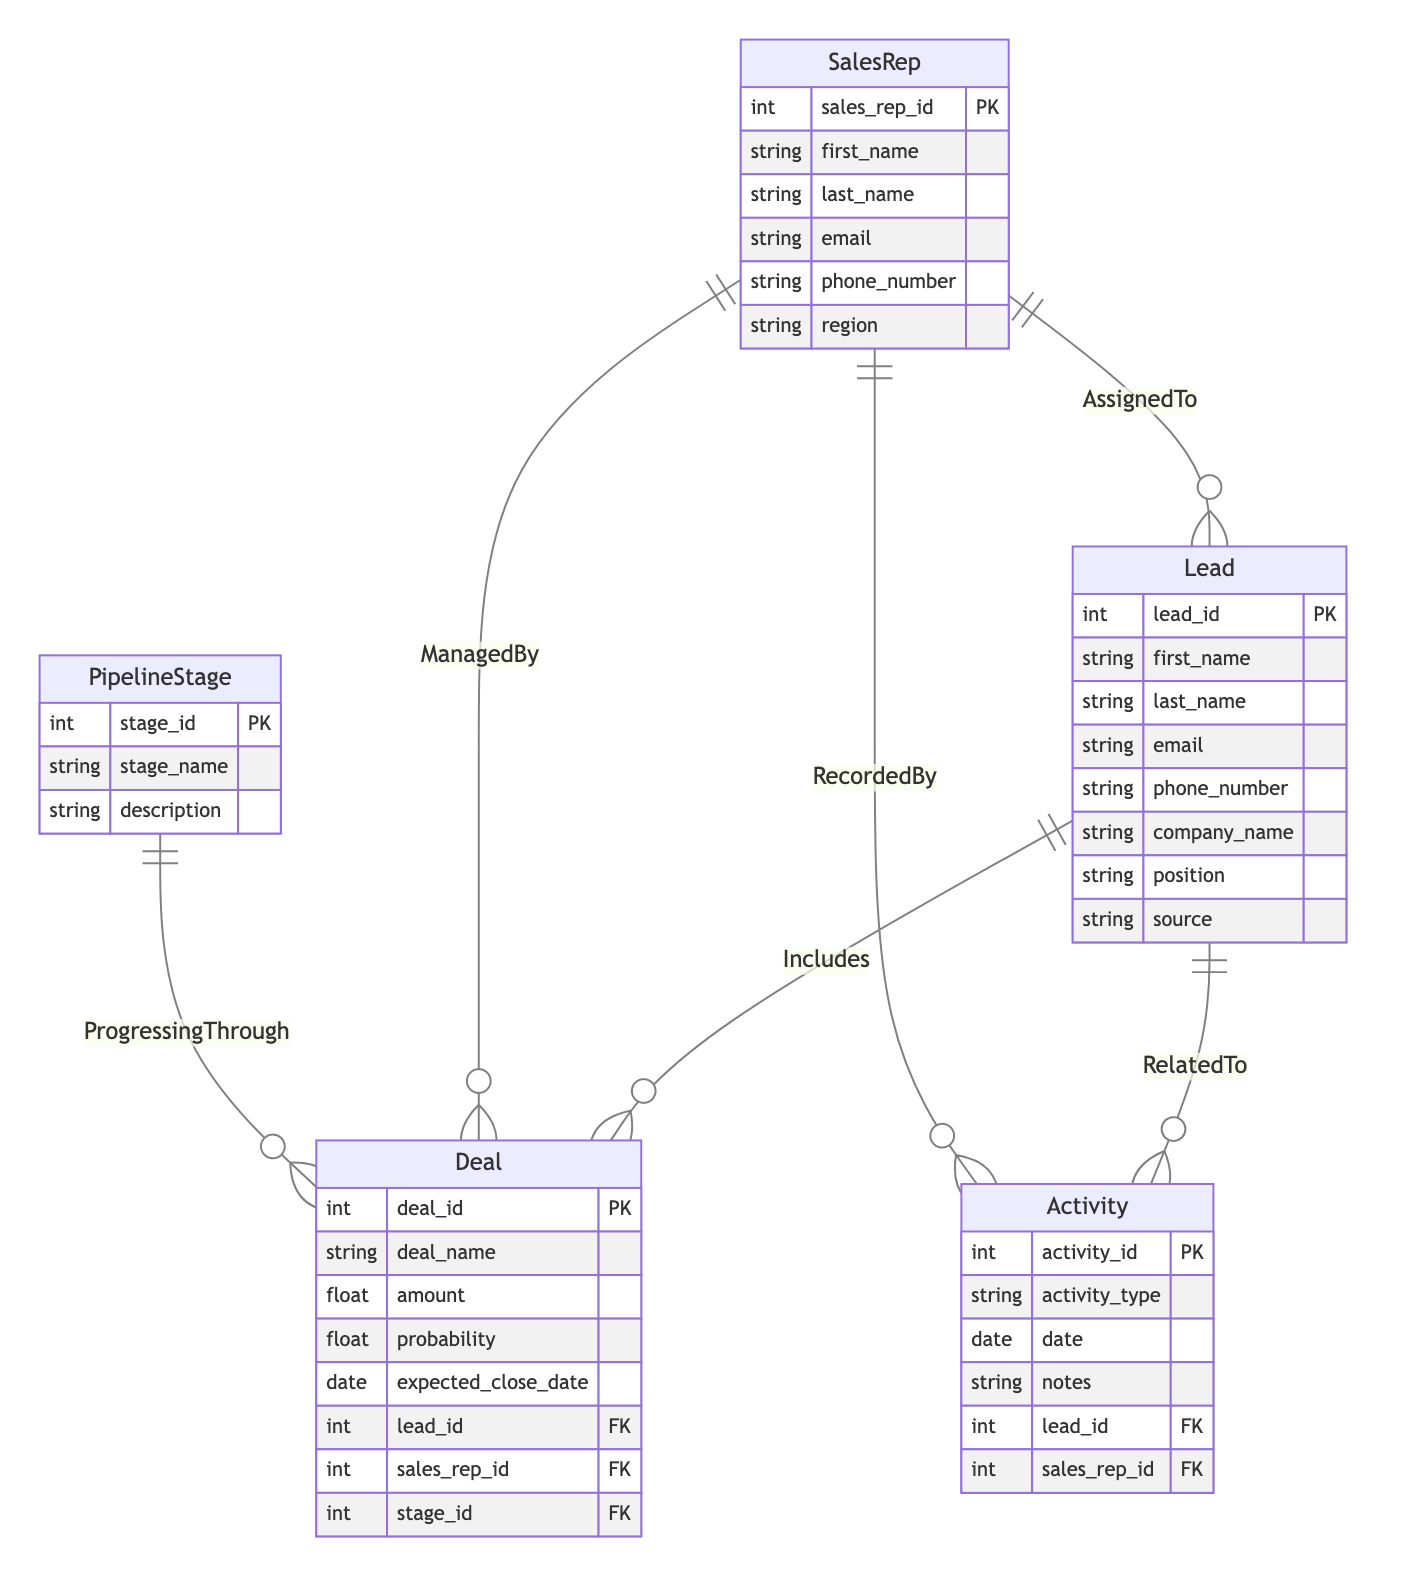What is the primary key of the Lead entity? The primary key of the Lead entity is designated by "PK" in the attributes list, which identifies lead_id as the unique identifier for each lead in this entity.
Answer: lead_id How many entities are present in the diagram? By counting the number of defined entities listed in the diagram, we find that there are five entities: Lead, SalesRep, PipelineStage, Deal, and Activity.
Answer: 5 What is the relationship type between Deal and PipelineStage? The relationship between Deal and PipelineStage is indicated as "ManyToOne," meaning multiple Deals can progress through a single PipelineStage, which is denoted in the relationships section.
Answer: ManyToOne Which entity is related to the Activity entity? According to the relationships in the diagram, the Activity entity has relationships with both Lead and SalesRep, indicating its connection to these two entities.
Answer: Lead, SalesRep How many Foreign Keys does the Deal entity have? The Deal entity has three Foreign Keys as indicated by the "FK" notation next to the attributes lead_id, sales_rep_id, and stage_id, which connect it to the Lead, SalesRep, and PipelineStage entities respectively.
Answer: 3 What does the AssignedTo relationship signify? The AssignedTo relationship highlights that each Lead can be assigned to one SalesRep, suggesting that a SalesRep can manage multiple Leads, as illustrated by the "ManyToOne" notation.
Answer: SalesRep Which entity contains the attribute "expected_close_date"? The Deal entity includes the attribute "expected_close_date," which is essential for tracking the anticipated closing date of deals.
Answer: Deal How many attributes does the SalesRep entity have? By reviewing the attributes listed under the SalesRep entity, we find that it contains six attributes, including the primary key sales_rep_id and other identifying information.
Answer: 6 What kind of relationship does the Includes connection indicate? The Includes connection indicates a "ManyToOne" relationship, suggesting that multiple Deals can be connected to a single Lead, as seen in the diagram's relationships section.
Answer: ManyToOne 